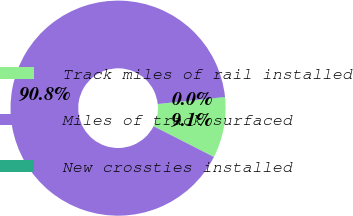Convert chart. <chart><loc_0><loc_0><loc_500><loc_500><pie_chart><fcel>Track miles of rail installed<fcel>Miles of track surfaced<fcel>New crossties installed<nl><fcel>9.12%<fcel>90.85%<fcel>0.04%<nl></chart> 